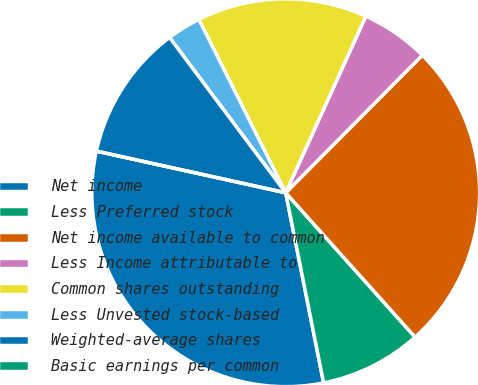Convert chart to OTSL. <chart><loc_0><loc_0><loc_500><loc_500><pie_chart><fcel>Net income<fcel>Less Preferred stock<fcel>Net income available to common<fcel>Less Income attributable to<fcel>Common shares outstanding<fcel>Less Unvested stock-based<fcel>Weighted-average shares<fcel>Basic earnings per common<nl><fcel>31.58%<fcel>8.5%<fcel>25.92%<fcel>5.67%<fcel>14.17%<fcel>2.83%<fcel>11.33%<fcel>0.0%<nl></chart> 